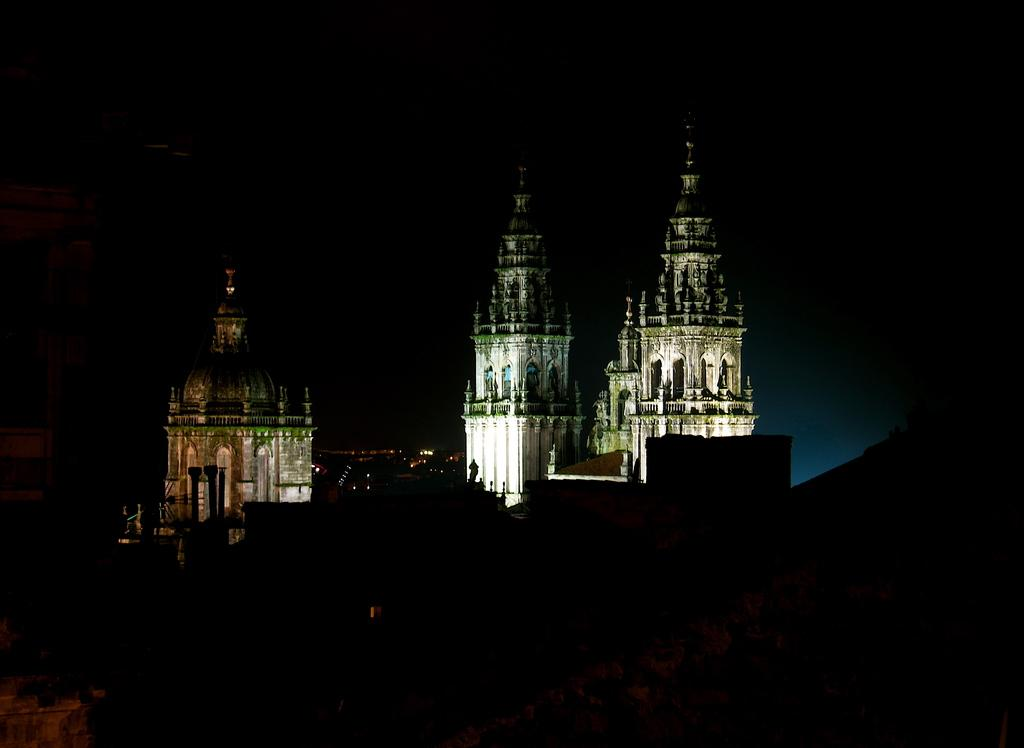What type of structures are visible in the image? There are buildings with lights in the image. How would you describe the overall color of the background in the image? The background of the image is dark in color. Can you tell me how many people are talking on the wall in the image? There are no people or walls present in the image; it features buildings with lights and a dark background. 